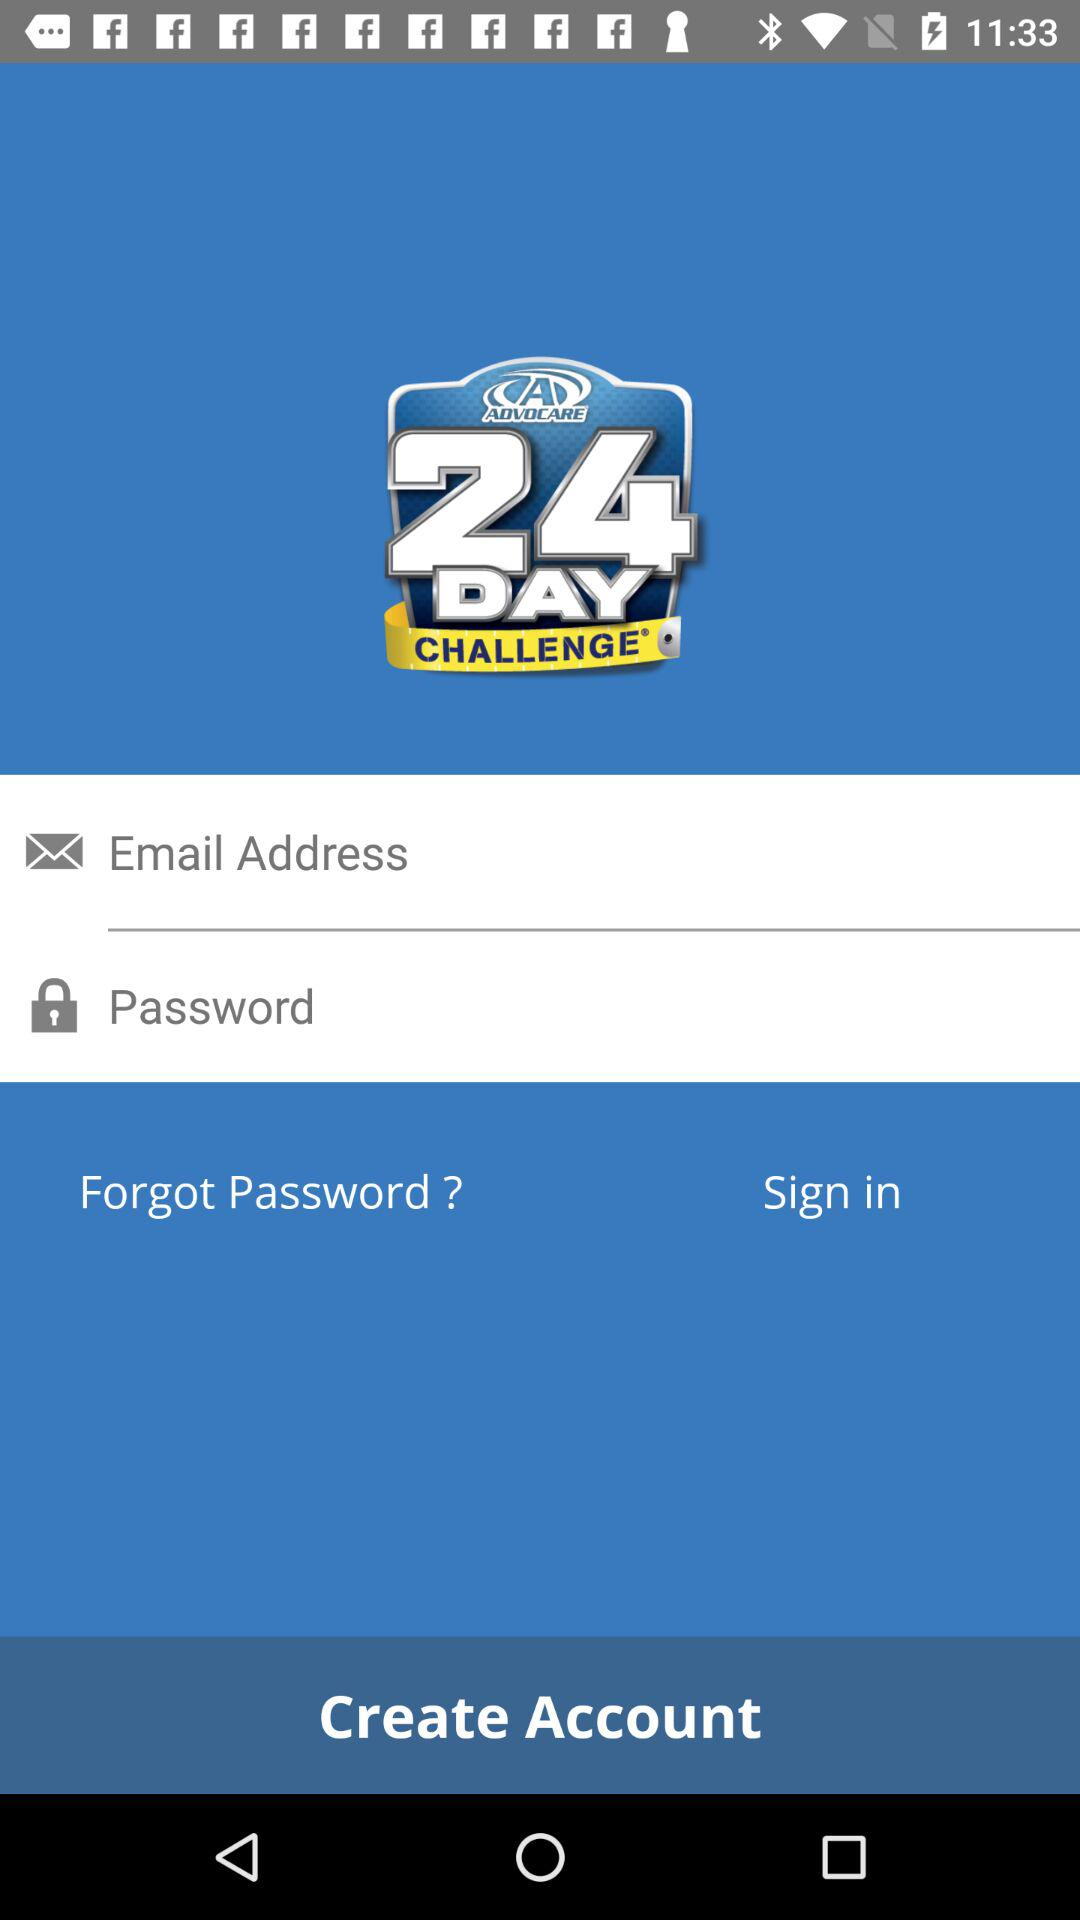What is the name of the application? The name of the application is "ADVOCARE 24 DAY CHALLENGE". 